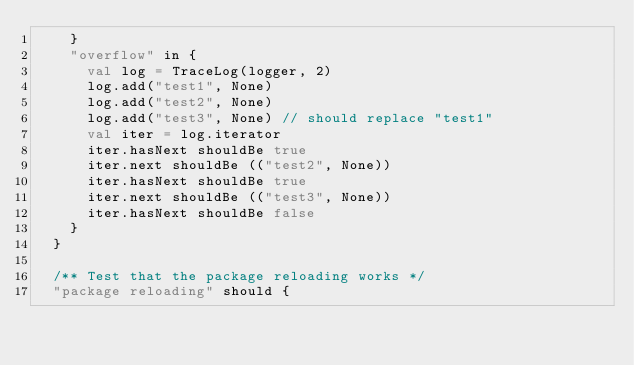<code> <loc_0><loc_0><loc_500><loc_500><_Scala_>    }
    "overflow" in {
      val log = TraceLog(logger, 2)
      log.add("test1", None)
      log.add("test2", None)
      log.add("test3", None) // should replace "test1"
      val iter = log.iterator
      iter.hasNext shouldBe true
      iter.next shouldBe (("test2", None))
      iter.hasNext shouldBe true
      iter.next shouldBe (("test3", None))
      iter.hasNext shouldBe false
    }
  }

  /** Test that the package reloading works */
  "package reloading" should {</code> 